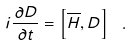<formula> <loc_0><loc_0><loc_500><loc_500>i \frac { \partial D } { \partial t } = \left [ { \overline { H } } , D \right ] \ .</formula> 